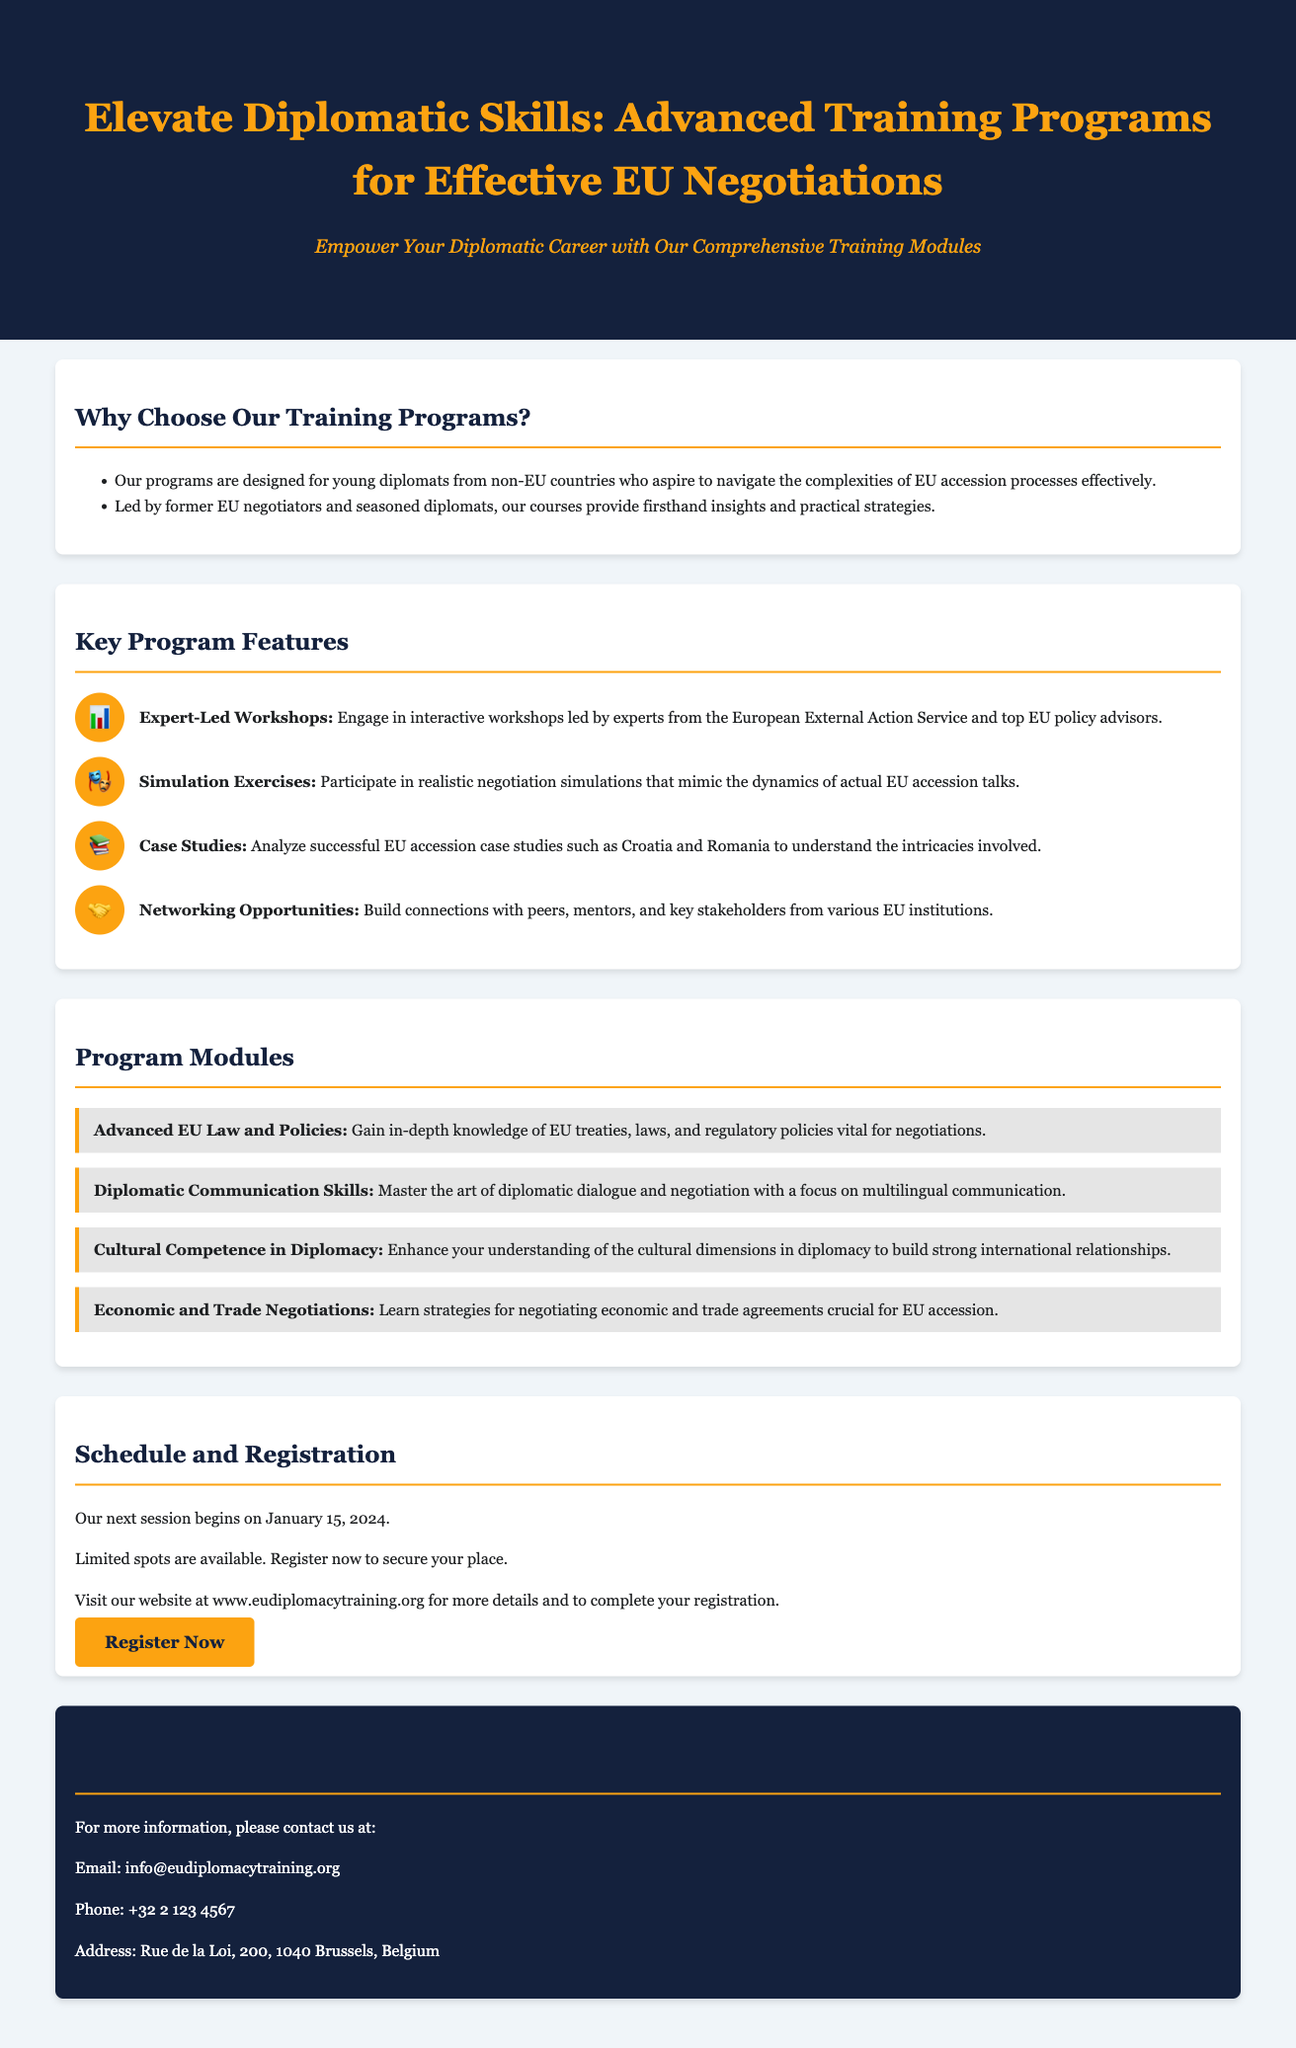What is the title of the training program? The title of the training program is presented at the top of the document, emphasizing its focus on enhancing diplomatic skills for effective EU negotiations.
Answer: Elevate Diplomatic Skills: Advanced Training Programs for Effective EU Negotiations When does the next session begin? The document states the starting date for the next training session, which provides important scheduling information for interested participants.
Answer: January 15, 2024 Who leads the workshops? The document specifies the qualifications of the instructors, highlighting their expertise and background to assure potential attendees of the program's quality.
Answer: Former EU negotiators and seasoned diplomats What type of exercises do participants engage in? The document outlines the interactive elements of the training program, particularly the realistic simulations that are part of the curriculum.
Answer: Negotiation simulations How many program modules are listed? The document provides a clear count of the different modules offered in the training program, which gives a sense of the program's breadth.
Answer: Four What is included in the 'Cultural Competence in Diplomacy' module? This question requires reasoning about the content of one specific module to gain insight into what skills and knowledge are taught.
Answer: Understanding of cultural dimensions in diplomacy How can I register for the program? The document mentions a specific action that interested individuals can take to sign up for the training program, reflecting the availability of enrollment options.
Answer: Visit our website at www.eudiplomacytraining.org What is the main target audience of the program? The document defines the specific group of individuals for whom the program is designed, indicating the primary beneficiaries of the training.
Answer: Young diplomats from non-EU countries 